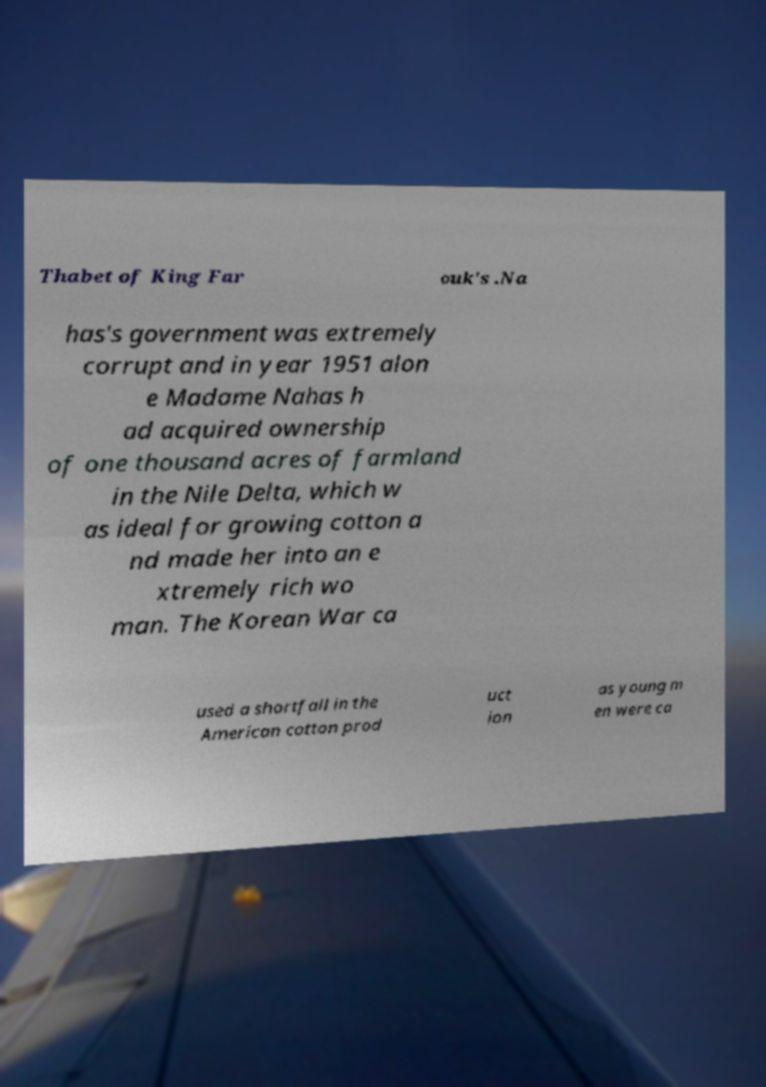There's text embedded in this image that I need extracted. Can you transcribe it verbatim? Thabet of King Far ouk's .Na has's government was extremely corrupt and in year 1951 alon e Madame Nahas h ad acquired ownership of one thousand acres of farmland in the Nile Delta, which w as ideal for growing cotton a nd made her into an e xtremely rich wo man. The Korean War ca used a shortfall in the American cotton prod uct ion as young m en were ca 